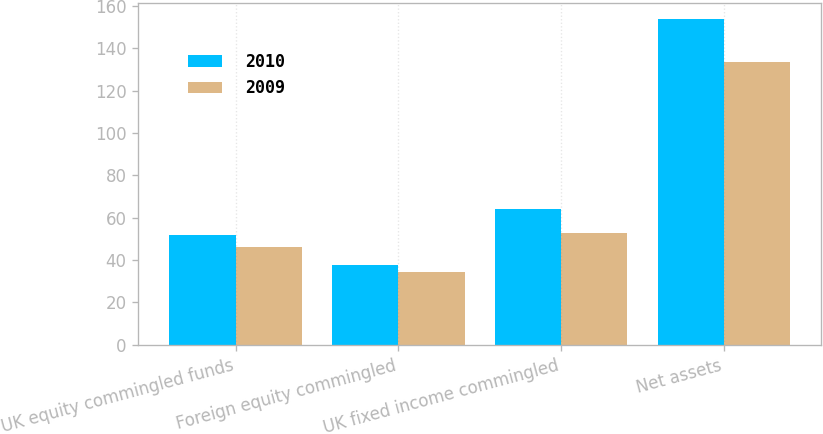Convert chart. <chart><loc_0><loc_0><loc_500><loc_500><stacked_bar_chart><ecel><fcel>UK equity commingled funds<fcel>Foreign equity commingled<fcel>UK fixed income commingled<fcel>Net assets<nl><fcel>2010<fcel>51.8<fcel>37.6<fcel>64.3<fcel>153.7<nl><fcel>2009<fcel>46.3<fcel>34.2<fcel>53<fcel>133.5<nl></chart> 